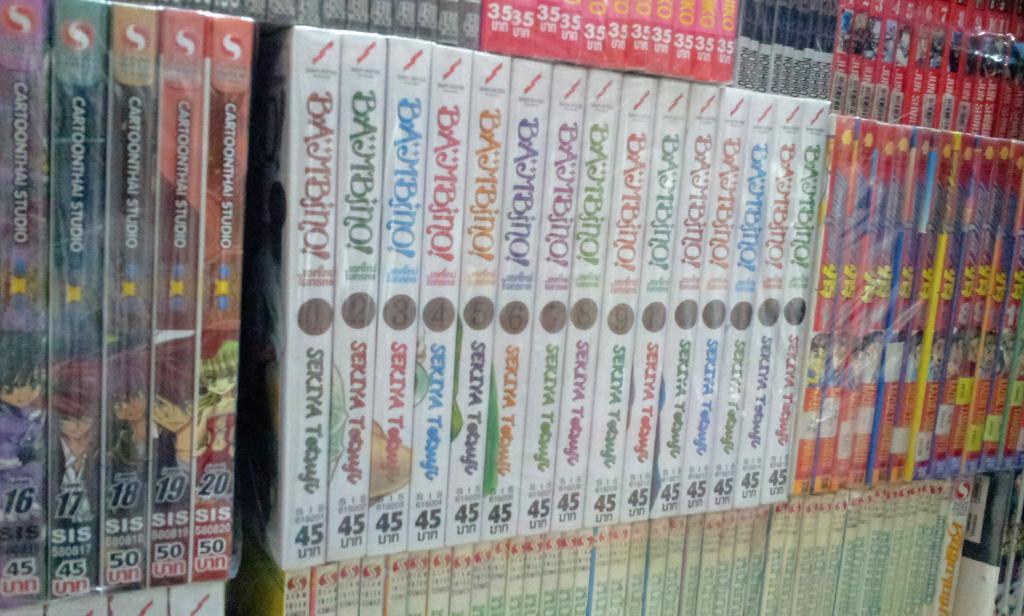What number is on the white books?
Your answer should be very brief. 45. Which studio published the collection on the left?
Give a very brief answer. Cartoonthai studio. 